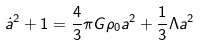<formula> <loc_0><loc_0><loc_500><loc_500>\dot { a } ^ { 2 } + 1 = \frac { 4 } { 3 } \pi G \rho _ { 0 } a ^ { 2 } + \frac { 1 } { 3 } \Lambda a ^ { 2 }</formula> 